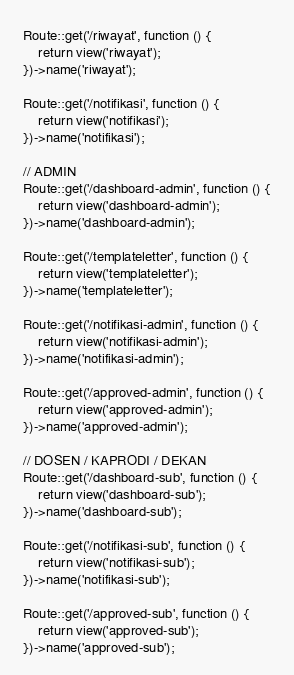Convert code to text. <code><loc_0><loc_0><loc_500><loc_500><_PHP_>Route::get('/riwayat', function () {
    return view('riwayat');
})->name('riwayat');

Route::get('/notifikasi', function () {
    return view('notifikasi');
})->name('notifikasi');

// ADMIN
Route::get('/dashboard-admin', function () {
    return view('dashboard-admin');
})->name('dashboard-admin');

Route::get('/templateletter', function () {
    return view('templateletter');
})->name('templateletter');

Route::get('/notifikasi-admin', function () {
    return view('notifikasi-admin');
})->name('notifikasi-admin');

Route::get('/approved-admin', function () {
    return view('approved-admin');
})->name('approved-admin');

// DOSEN / KAPRODI / DEKAN
Route::get('/dashboard-sub', function () {
    return view('dashboard-sub');
})->name('dashboard-sub');

Route::get('/notifikasi-sub', function () {
    return view('notifikasi-sub');
})->name('notifikasi-sub');

Route::get('/approved-sub', function () {
    return view('approved-sub');
})->name('approved-sub');
</code> 